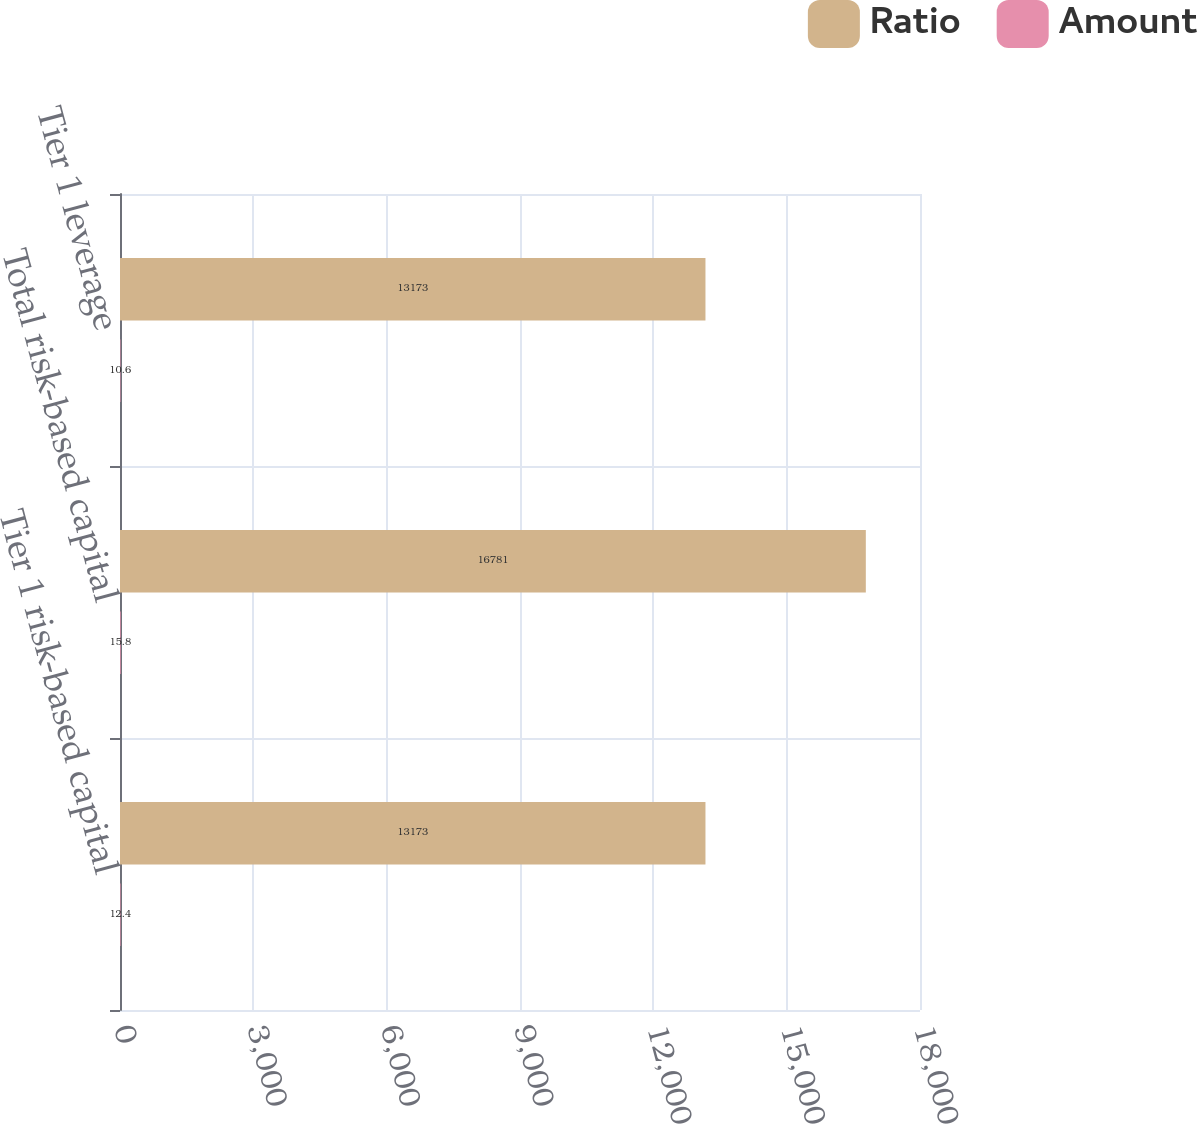Convert chart. <chart><loc_0><loc_0><loc_500><loc_500><stacked_bar_chart><ecel><fcel>Tier 1 risk-based capital<fcel>Total risk-based capital<fcel>Tier 1 leverage<nl><fcel>Ratio<fcel>13173<fcel>16781<fcel>13173<nl><fcel>Amount<fcel>12.4<fcel>15.8<fcel>10.6<nl></chart> 